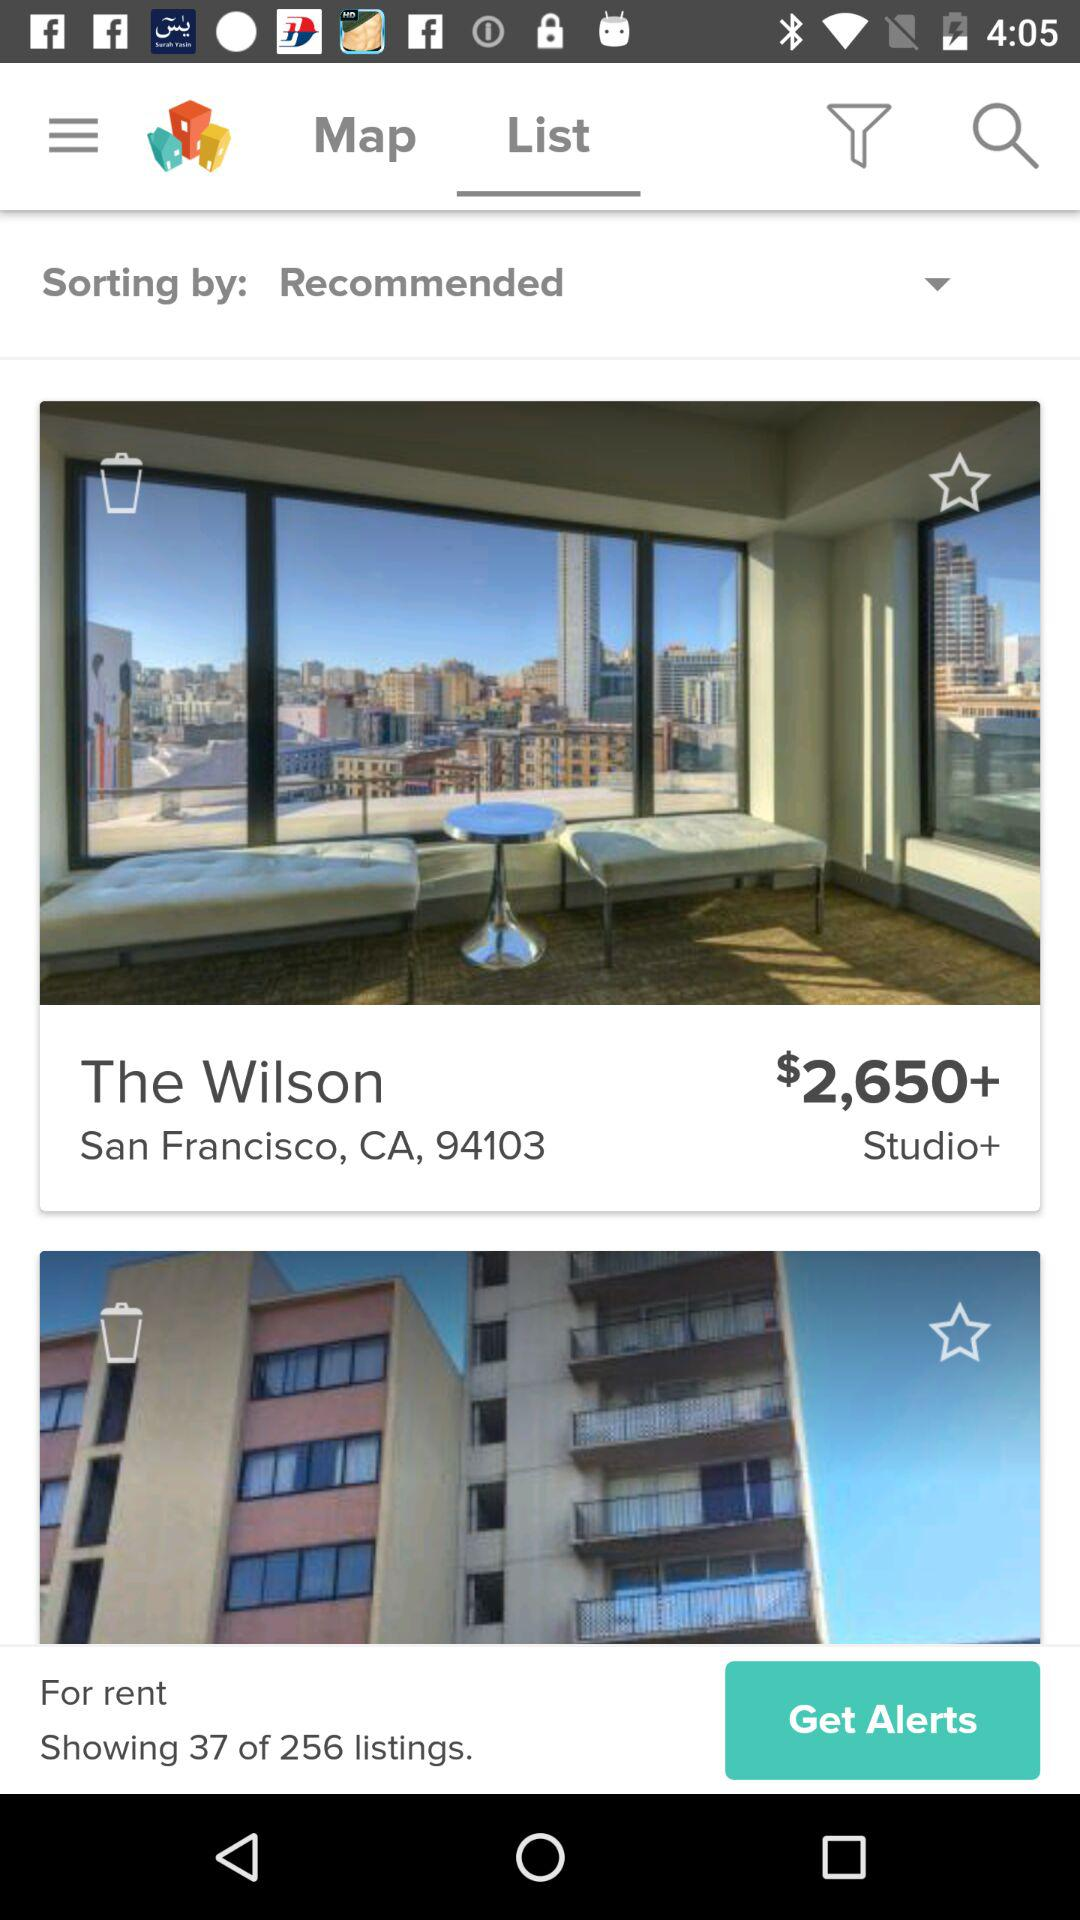What is the address of "The Wilson"? The address of "The Wilson" is San Francisco, CA, 94103. 